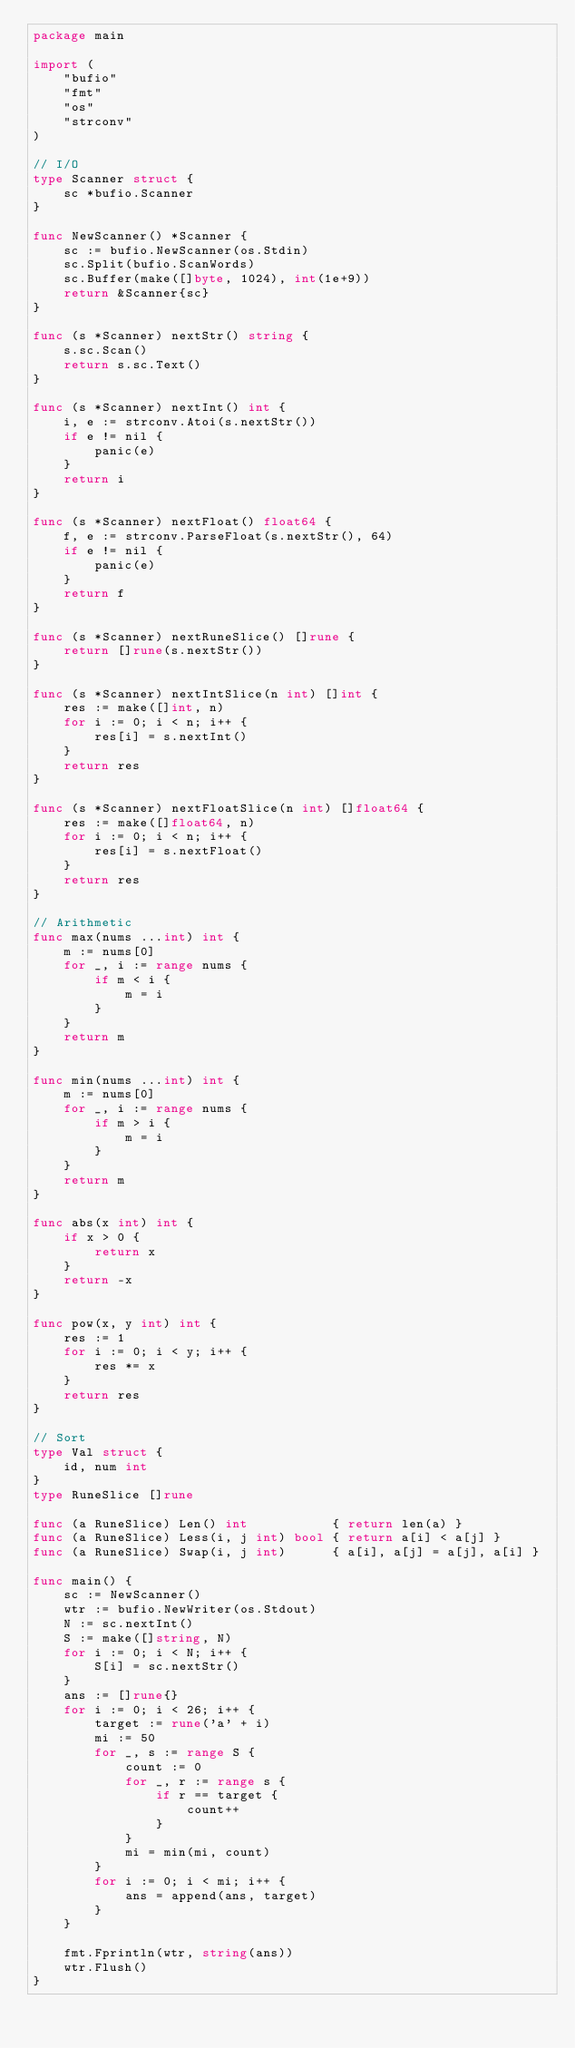Convert code to text. <code><loc_0><loc_0><loc_500><loc_500><_Go_>package main

import (
	"bufio"
	"fmt"
	"os"
	"strconv"
)

// I/O
type Scanner struct {
	sc *bufio.Scanner
}

func NewScanner() *Scanner {
	sc := bufio.NewScanner(os.Stdin)
	sc.Split(bufio.ScanWords)
	sc.Buffer(make([]byte, 1024), int(1e+9))
	return &Scanner{sc}
}

func (s *Scanner) nextStr() string {
	s.sc.Scan()
	return s.sc.Text()
}

func (s *Scanner) nextInt() int {
	i, e := strconv.Atoi(s.nextStr())
	if e != nil {
		panic(e)
	}
	return i
}

func (s *Scanner) nextFloat() float64 {
	f, e := strconv.ParseFloat(s.nextStr(), 64)
	if e != nil {
		panic(e)
	}
	return f
}

func (s *Scanner) nextRuneSlice() []rune {
	return []rune(s.nextStr())
}

func (s *Scanner) nextIntSlice(n int) []int {
	res := make([]int, n)
	for i := 0; i < n; i++ {
		res[i] = s.nextInt()
	}
	return res
}

func (s *Scanner) nextFloatSlice(n int) []float64 {
	res := make([]float64, n)
	for i := 0; i < n; i++ {
		res[i] = s.nextFloat()
	}
	return res
}

// Arithmetic
func max(nums ...int) int {
	m := nums[0]
	for _, i := range nums {
		if m < i {
			m = i
		}
	}
	return m
}

func min(nums ...int) int {
	m := nums[0]
	for _, i := range nums {
		if m > i {
			m = i
		}
	}
	return m
}

func abs(x int) int {
	if x > 0 {
		return x
	}
	return -x
}

func pow(x, y int) int {
	res := 1
	for i := 0; i < y; i++ {
		res *= x
	}
	return res
}

// Sort
type Val struct {
	id, num int
}
type RuneSlice []rune

func (a RuneSlice) Len() int           { return len(a) }
func (a RuneSlice) Less(i, j int) bool { return a[i] < a[j] }
func (a RuneSlice) Swap(i, j int)      { a[i], a[j] = a[j], a[i] }

func main() {
	sc := NewScanner()
	wtr := bufio.NewWriter(os.Stdout)
	N := sc.nextInt()
	S := make([]string, N)
	for i := 0; i < N; i++ {
		S[i] = sc.nextStr()
	}
	ans := []rune{}
	for i := 0; i < 26; i++ {
		target := rune('a' + i)
		mi := 50
		for _, s := range S {
			count := 0
			for _, r := range s {
				if r == target {
					count++
				}
			}
			mi = min(mi, count)
		}
		for i := 0; i < mi; i++ {
			ans = append(ans, target)
		}
	}

	fmt.Fprintln(wtr, string(ans))
	wtr.Flush()
}
</code> 